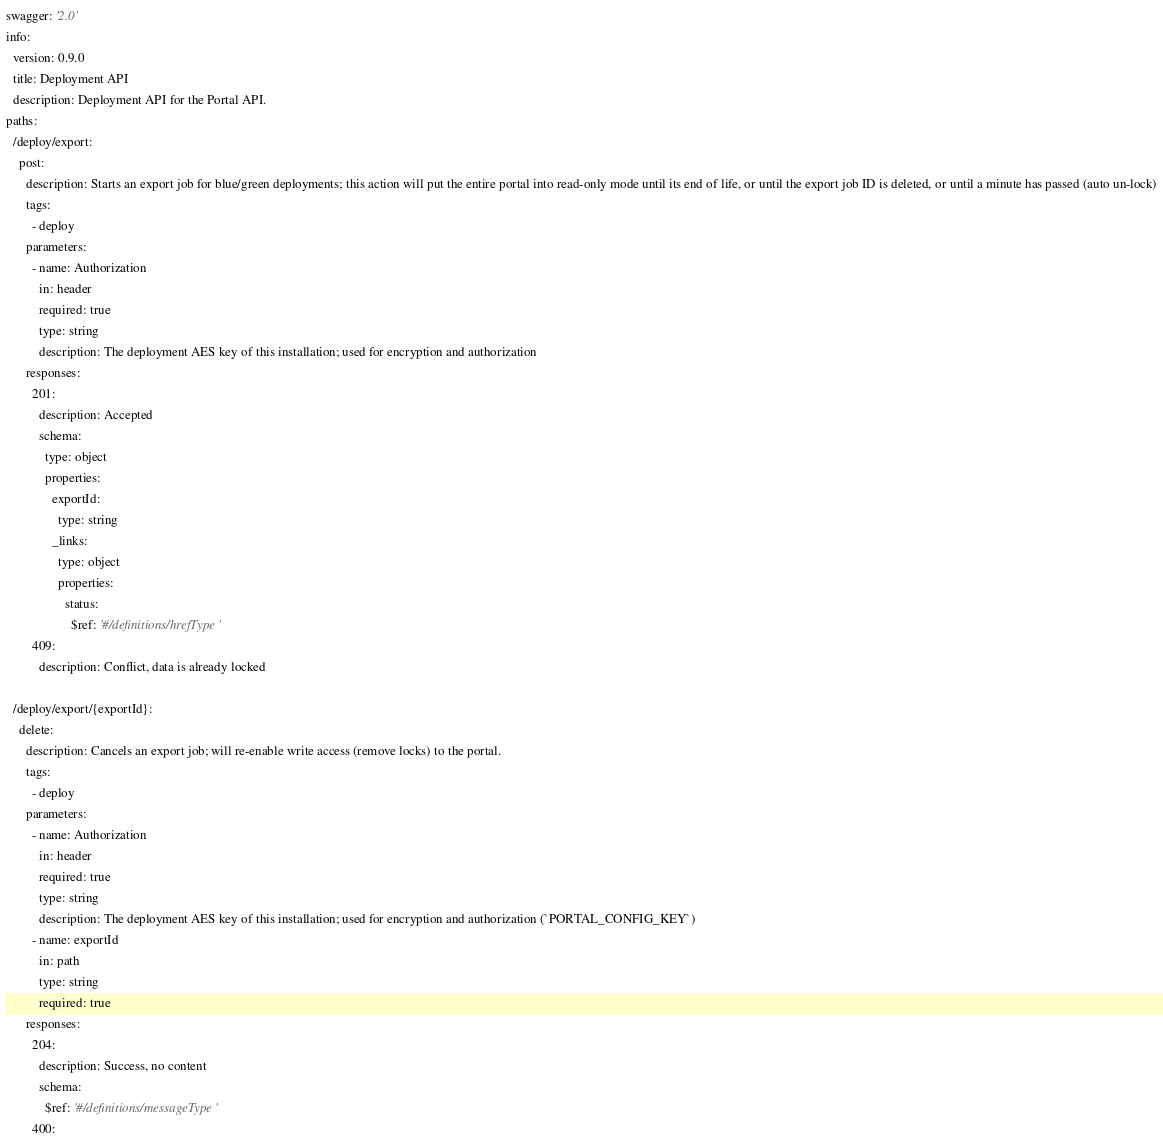<code> <loc_0><loc_0><loc_500><loc_500><_YAML_>swagger: '2.0'
info:
  version: 0.9.0
  title: Deployment API
  description: Deployment API for the Portal API.
paths:
  /deploy/export:
    post:
      description: Starts an export job for blue/green deployments; this action will put the entire portal into read-only mode until its end of life, or until the export job ID is deleted, or until a minute has passed (auto un-lock)
      tags:
        - deploy
      parameters:
        - name: Authorization
          in: header
          required: true
          type: string
          description: The deployment AES key of this installation; used for encryption and authorization
      responses:
        201:
          description: Accepted
          schema:
            type: object
            properties:
              exportId:
                type: string
              _links:
                type: object
                properties:
                  status:
                    $ref: '#/definitions/hrefType'
        409:
          description: Conflict, data is already locked

  /deploy/export/{exportId}:
    delete:
      description: Cancels an export job; will re-enable write access (remove locks) to the portal.
      tags:
        - deploy
      parameters:
        - name: Authorization
          in: header
          required: true
          type: string
          description: The deployment AES key of this installation; used for encryption and authorization (`PORTAL_CONFIG_KEY`)
        - name: exportId
          in: path
          type: string
          required: true
      responses:
        204:
          description: Success, no content
          schema:
            $ref: '#/definitions/messageType'
        400:</code> 